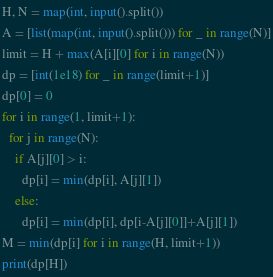<code> <loc_0><loc_0><loc_500><loc_500><_Python_>H, N = map(int, input().split())
A = [list(map(int, input().split())) for _ in range(N)]
limit = H + max(A[i][0] for i in range(N))
dp = [int(1e18) for _ in range(limit+1)]
dp[0] = 0
for i in range(1, limit+1):
  for j in range(N):
    if A[j][0] > i:
      dp[i] = min(dp[i], A[j][1])
    else:
      dp[i] = min(dp[i], dp[i-A[j][0]]+A[j][1])
M = min(dp[i] for i in range(H, limit+1))
print(dp[H])</code> 